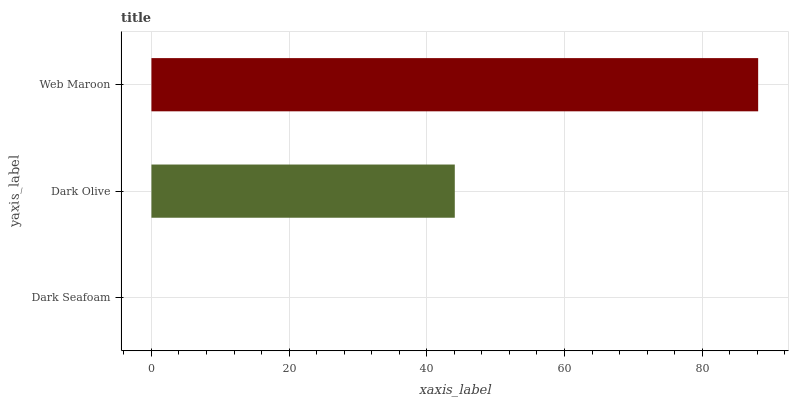Is Dark Seafoam the minimum?
Answer yes or no. Yes. Is Web Maroon the maximum?
Answer yes or no. Yes. Is Dark Olive the minimum?
Answer yes or no. No. Is Dark Olive the maximum?
Answer yes or no. No. Is Dark Olive greater than Dark Seafoam?
Answer yes or no. Yes. Is Dark Seafoam less than Dark Olive?
Answer yes or no. Yes. Is Dark Seafoam greater than Dark Olive?
Answer yes or no. No. Is Dark Olive less than Dark Seafoam?
Answer yes or no. No. Is Dark Olive the high median?
Answer yes or no. Yes. Is Dark Olive the low median?
Answer yes or no. Yes. Is Dark Seafoam the high median?
Answer yes or no. No. Is Web Maroon the low median?
Answer yes or no. No. 